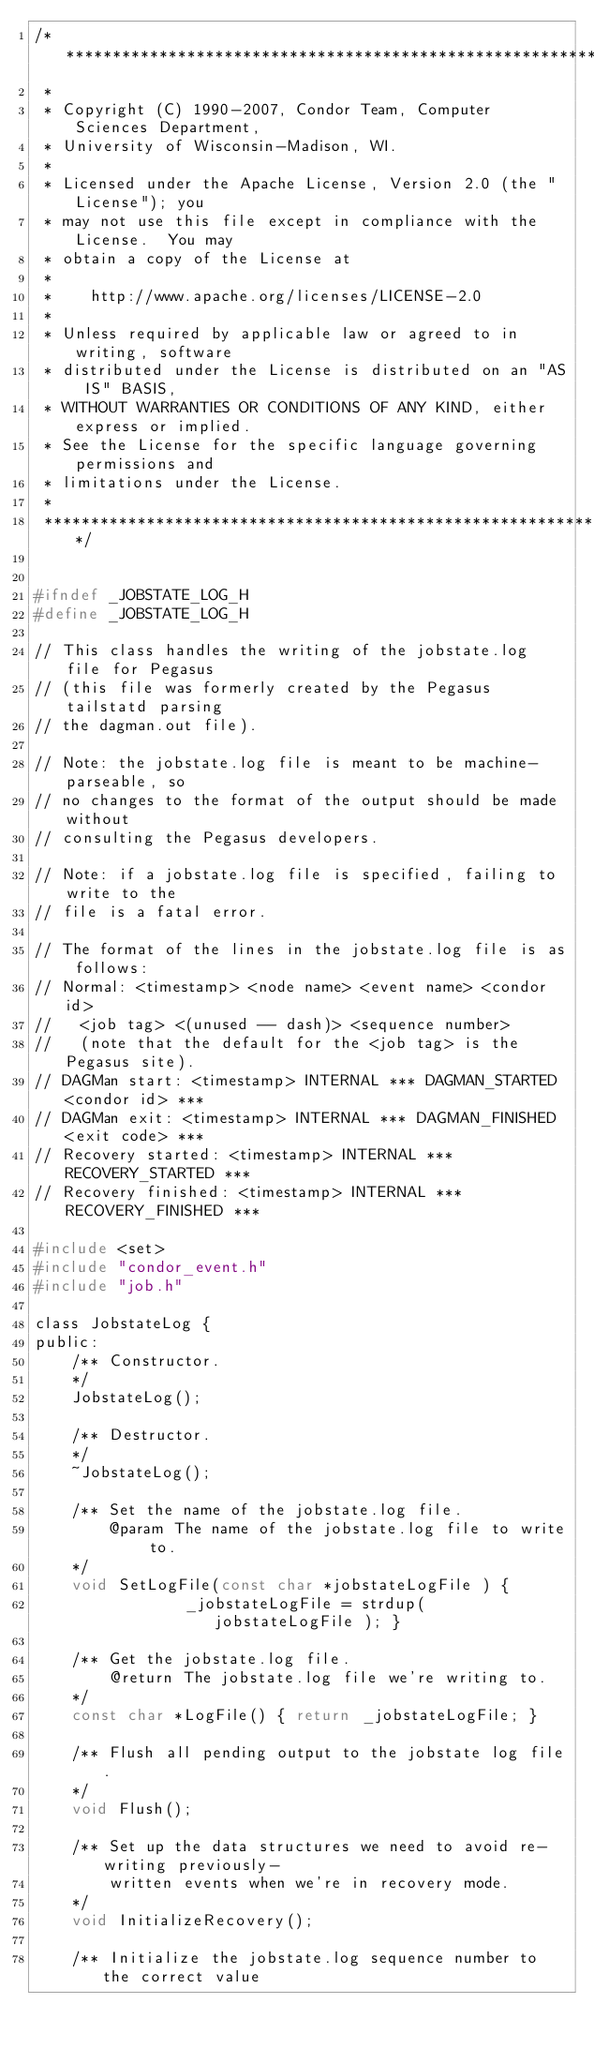<code> <loc_0><loc_0><loc_500><loc_500><_C_>/***************************************************************
 *
 * Copyright (C) 1990-2007, Condor Team, Computer Sciences Department,
 * University of Wisconsin-Madison, WI.
 * 
 * Licensed under the Apache License, Version 2.0 (the "License"); you
 * may not use this file except in compliance with the License.  You may
 * obtain a copy of the License at
 * 
 *    http://www.apache.org/licenses/LICENSE-2.0
 * 
 * Unless required by applicable law or agreed to in writing, software
 * distributed under the License is distributed on an "AS IS" BASIS,
 * WITHOUT WARRANTIES OR CONDITIONS OF ANY KIND, either express or implied.
 * See the License for the specific language governing permissions and
 * limitations under the License.
 *
 ***************************************************************/


#ifndef _JOBSTATE_LOG_H
#define _JOBSTATE_LOG_H

// This class handles the writing of the jobstate.log file for Pegasus
// (this file was formerly created by the Pegasus tailstatd parsing
// the dagman.out file).

// Note: the jobstate.log file is meant to be machine-parseable, so
// no changes to the format of the output should be made without
// consulting the Pegasus developers.

// Note: if a jobstate.log file is specified, failing to write to the
// file is a fatal error.

// The format of the lines in the jobstate.log file is as follows:
// Normal: <timestamp> <node name> <event name> <condor id>
//   <job tag> <(unused -- dash)> <sequence number>
//   (note that the default for the <job tag> is the Pegasus site).
// DAGMan start: <timestamp> INTERNAL *** DAGMAN_STARTED <condor id> ***
// DAGMan exit: <timestamp> INTERNAL *** DAGMAN_FINISHED <exit code> ***
// Recovery started: <timestamp> INTERNAL *** RECOVERY_STARTED ***
// Recovery finished: <timestamp> INTERNAL *** RECOVERY_FINISHED ***

#include <set>
#include "condor_event.h"
#include "job.h"

class JobstateLog {
public:
	/** Constructor.
	*/
	JobstateLog();

	/** Destructor.
	*/
	~JobstateLog();

	/** Set the name of the jobstate.log file.
		@param The name of the jobstate.log file to write to.
	*/
	void SetLogFile(const char *jobstateLogFile ) {
				_jobstateLogFile = strdup( jobstateLogFile ); }

	/** Get the jobstate.log file.
		@return The jobstate.log file we're writing to.
	*/
	const char *LogFile() { return _jobstateLogFile; }

	/** Flush all pending output to the jobstate log file.
	*/
	void Flush();

	/** Set up the data structures we need to avoid re-writing previously-
		written events when we're in recovery mode.
	*/
	void InitializeRecovery();

	/** Initialize the jobstate.log sequence number to the correct value</code> 